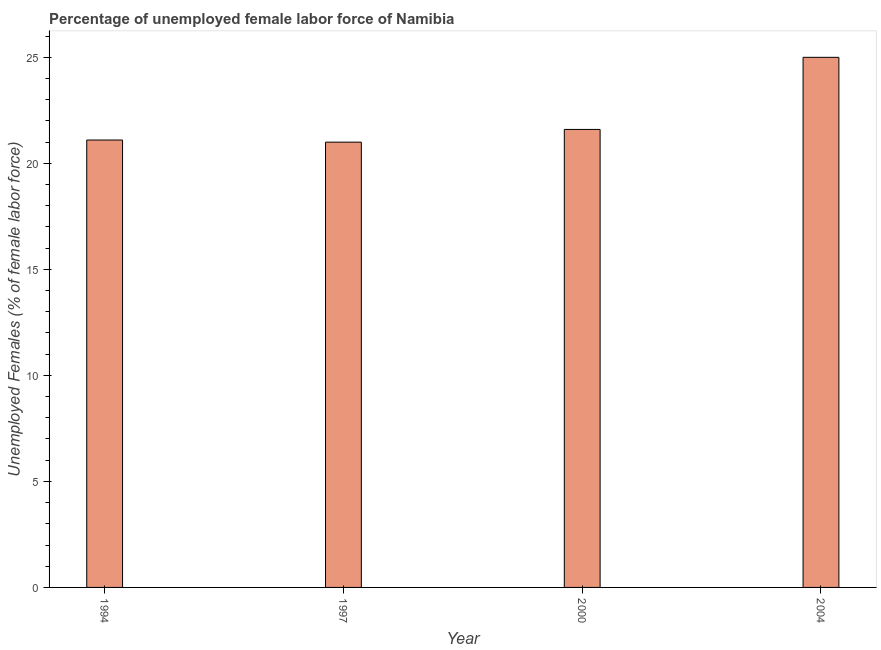Does the graph contain grids?
Keep it short and to the point. No. What is the title of the graph?
Keep it short and to the point. Percentage of unemployed female labor force of Namibia. What is the label or title of the X-axis?
Provide a succinct answer. Year. What is the label or title of the Y-axis?
Keep it short and to the point. Unemployed Females (% of female labor force). What is the total unemployed female labour force in 1994?
Your answer should be compact. 21.1. In which year was the total unemployed female labour force maximum?
Keep it short and to the point. 2004. What is the sum of the total unemployed female labour force?
Keep it short and to the point. 88.7. What is the average total unemployed female labour force per year?
Offer a very short reply. 22.18. What is the median total unemployed female labour force?
Your answer should be compact. 21.35. Do a majority of the years between 2000 and 2004 (inclusive) have total unemployed female labour force greater than 10 %?
Provide a succinct answer. Yes. What is the ratio of the total unemployed female labour force in 1997 to that in 2004?
Your answer should be very brief. 0.84. Is the total unemployed female labour force in 2000 less than that in 2004?
Provide a succinct answer. Yes. Is the difference between the total unemployed female labour force in 1994 and 2004 greater than the difference between any two years?
Keep it short and to the point. No. Are all the bars in the graph horizontal?
Ensure brevity in your answer.  No. What is the difference between two consecutive major ticks on the Y-axis?
Provide a succinct answer. 5. Are the values on the major ticks of Y-axis written in scientific E-notation?
Ensure brevity in your answer.  No. What is the Unemployed Females (% of female labor force) of 1994?
Your response must be concise. 21.1. What is the Unemployed Females (% of female labor force) of 1997?
Your answer should be very brief. 21. What is the Unemployed Females (% of female labor force) in 2000?
Provide a short and direct response. 21.6. What is the difference between the Unemployed Females (% of female labor force) in 1994 and 1997?
Keep it short and to the point. 0.1. What is the difference between the Unemployed Females (% of female labor force) in 1997 and 2000?
Your response must be concise. -0.6. What is the difference between the Unemployed Females (% of female labor force) in 1997 and 2004?
Offer a terse response. -4. What is the ratio of the Unemployed Females (% of female labor force) in 1994 to that in 2000?
Offer a very short reply. 0.98. What is the ratio of the Unemployed Females (% of female labor force) in 1994 to that in 2004?
Offer a very short reply. 0.84. What is the ratio of the Unemployed Females (% of female labor force) in 1997 to that in 2004?
Keep it short and to the point. 0.84. What is the ratio of the Unemployed Females (% of female labor force) in 2000 to that in 2004?
Give a very brief answer. 0.86. 